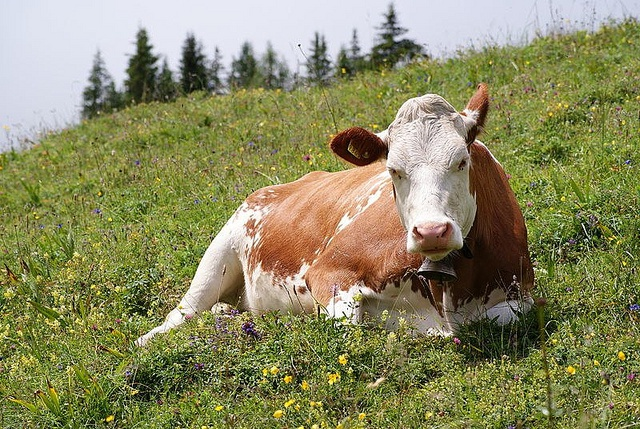Describe the objects in this image and their specific colors. I can see a cow in lavender, white, black, tan, and maroon tones in this image. 